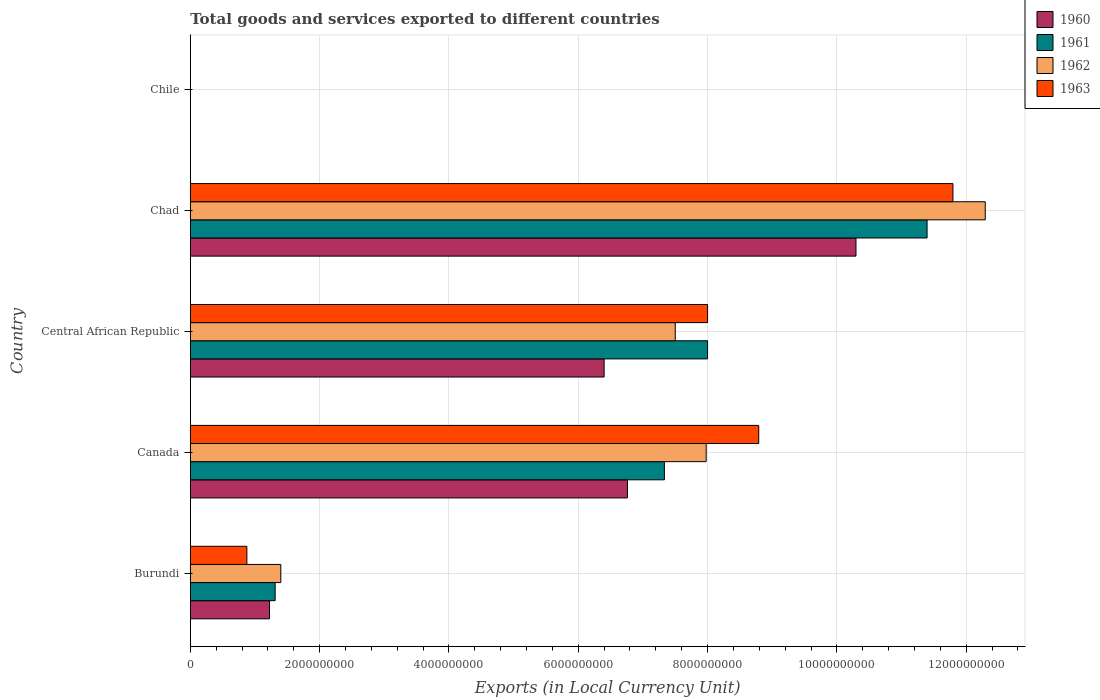How many different coloured bars are there?
Your response must be concise. 4. Are the number of bars per tick equal to the number of legend labels?
Offer a very short reply. Yes. How many bars are there on the 3rd tick from the bottom?
Make the answer very short. 4. What is the label of the 2nd group of bars from the top?
Keep it short and to the point. Chad. In how many cases, is the number of bars for a given country not equal to the number of legend labels?
Your answer should be compact. 0. What is the Amount of goods and services exports in 1962 in Burundi?
Provide a succinct answer. 1.40e+09. Across all countries, what is the maximum Amount of goods and services exports in 1963?
Give a very brief answer. 1.18e+1. Across all countries, what is the minimum Amount of goods and services exports in 1963?
Keep it short and to the point. 1.10e+06. In which country was the Amount of goods and services exports in 1961 maximum?
Offer a very short reply. Chad. What is the total Amount of goods and services exports in 1962 in the graph?
Your answer should be very brief. 2.92e+1. What is the difference between the Amount of goods and services exports in 1963 in Canada and that in Central African Republic?
Your response must be concise. 7.91e+08. What is the difference between the Amount of goods and services exports in 1960 in Chile and the Amount of goods and services exports in 1961 in Canada?
Provide a succinct answer. -7.33e+09. What is the average Amount of goods and services exports in 1962 per country?
Your answer should be very brief. 5.83e+09. What is the difference between the Amount of goods and services exports in 1962 and Amount of goods and services exports in 1963 in Canada?
Offer a very short reply. -8.13e+08. What is the ratio of the Amount of goods and services exports in 1963 in Burundi to that in Chad?
Offer a terse response. 0.07. What is the difference between the highest and the second highest Amount of goods and services exports in 1960?
Provide a succinct answer. 3.53e+09. What is the difference between the highest and the lowest Amount of goods and services exports in 1962?
Make the answer very short. 1.23e+1. Is the sum of the Amount of goods and services exports in 1963 in Burundi and Central African Republic greater than the maximum Amount of goods and services exports in 1962 across all countries?
Offer a terse response. No. What does the 2nd bar from the bottom in Central African Republic represents?
Offer a terse response. 1961. Are all the bars in the graph horizontal?
Provide a short and direct response. Yes. How many countries are there in the graph?
Make the answer very short. 5. Does the graph contain grids?
Your response must be concise. Yes. Where does the legend appear in the graph?
Provide a short and direct response. Top right. How many legend labels are there?
Offer a very short reply. 4. How are the legend labels stacked?
Keep it short and to the point. Vertical. What is the title of the graph?
Keep it short and to the point. Total goods and services exported to different countries. What is the label or title of the X-axis?
Offer a very short reply. Exports (in Local Currency Unit). What is the Exports (in Local Currency Unit) in 1960 in Burundi?
Give a very brief answer. 1.22e+09. What is the Exports (in Local Currency Unit) in 1961 in Burundi?
Keep it short and to the point. 1.31e+09. What is the Exports (in Local Currency Unit) in 1962 in Burundi?
Ensure brevity in your answer.  1.40e+09. What is the Exports (in Local Currency Unit) in 1963 in Burundi?
Keep it short and to the point. 8.75e+08. What is the Exports (in Local Currency Unit) of 1960 in Canada?
Your answer should be compact. 6.76e+09. What is the Exports (in Local Currency Unit) of 1961 in Canada?
Ensure brevity in your answer.  7.33e+09. What is the Exports (in Local Currency Unit) in 1962 in Canada?
Give a very brief answer. 7.98e+09. What is the Exports (in Local Currency Unit) of 1963 in Canada?
Ensure brevity in your answer.  8.79e+09. What is the Exports (in Local Currency Unit) in 1960 in Central African Republic?
Offer a terse response. 6.40e+09. What is the Exports (in Local Currency Unit) in 1961 in Central African Republic?
Your answer should be compact. 8.00e+09. What is the Exports (in Local Currency Unit) in 1962 in Central African Republic?
Your response must be concise. 7.50e+09. What is the Exports (in Local Currency Unit) of 1963 in Central African Republic?
Provide a short and direct response. 8.00e+09. What is the Exports (in Local Currency Unit) in 1960 in Chad?
Your response must be concise. 1.03e+1. What is the Exports (in Local Currency Unit) in 1961 in Chad?
Your response must be concise. 1.14e+1. What is the Exports (in Local Currency Unit) in 1962 in Chad?
Keep it short and to the point. 1.23e+1. What is the Exports (in Local Currency Unit) in 1963 in Chad?
Provide a short and direct response. 1.18e+1. What is the Exports (in Local Currency Unit) of 1960 in Chile?
Make the answer very short. 6.00e+05. What is the Exports (in Local Currency Unit) of 1963 in Chile?
Provide a succinct answer. 1.10e+06. Across all countries, what is the maximum Exports (in Local Currency Unit) of 1960?
Make the answer very short. 1.03e+1. Across all countries, what is the maximum Exports (in Local Currency Unit) in 1961?
Make the answer very short. 1.14e+1. Across all countries, what is the maximum Exports (in Local Currency Unit) of 1962?
Keep it short and to the point. 1.23e+1. Across all countries, what is the maximum Exports (in Local Currency Unit) in 1963?
Your response must be concise. 1.18e+1. Across all countries, what is the minimum Exports (in Local Currency Unit) of 1963?
Offer a terse response. 1.10e+06. What is the total Exports (in Local Currency Unit) of 1960 in the graph?
Make the answer very short. 2.47e+1. What is the total Exports (in Local Currency Unit) of 1961 in the graph?
Provide a short and direct response. 2.80e+1. What is the total Exports (in Local Currency Unit) in 1962 in the graph?
Provide a short and direct response. 2.92e+1. What is the total Exports (in Local Currency Unit) of 1963 in the graph?
Your answer should be very brief. 2.95e+1. What is the difference between the Exports (in Local Currency Unit) of 1960 in Burundi and that in Canada?
Keep it short and to the point. -5.54e+09. What is the difference between the Exports (in Local Currency Unit) of 1961 in Burundi and that in Canada?
Keep it short and to the point. -6.02e+09. What is the difference between the Exports (in Local Currency Unit) in 1962 in Burundi and that in Canada?
Your answer should be compact. -6.58e+09. What is the difference between the Exports (in Local Currency Unit) of 1963 in Burundi and that in Canada?
Ensure brevity in your answer.  -7.92e+09. What is the difference between the Exports (in Local Currency Unit) of 1960 in Burundi and that in Central African Republic?
Make the answer very short. -5.18e+09. What is the difference between the Exports (in Local Currency Unit) in 1961 in Burundi and that in Central African Republic?
Make the answer very short. -6.69e+09. What is the difference between the Exports (in Local Currency Unit) of 1962 in Burundi and that in Central African Republic?
Keep it short and to the point. -6.10e+09. What is the difference between the Exports (in Local Currency Unit) in 1963 in Burundi and that in Central African Republic?
Provide a succinct answer. -7.12e+09. What is the difference between the Exports (in Local Currency Unit) of 1960 in Burundi and that in Chad?
Your answer should be compact. -9.07e+09. What is the difference between the Exports (in Local Currency Unit) in 1961 in Burundi and that in Chad?
Ensure brevity in your answer.  -1.01e+1. What is the difference between the Exports (in Local Currency Unit) of 1962 in Burundi and that in Chad?
Provide a succinct answer. -1.09e+1. What is the difference between the Exports (in Local Currency Unit) in 1963 in Burundi and that in Chad?
Your answer should be compact. -1.09e+1. What is the difference between the Exports (in Local Currency Unit) of 1960 in Burundi and that in Chile?
Your answer should be very brief. 1.22e+09. What is the difference between the Exports (in Local Currency Unit) in 1961 in Burundi and that in Chile?
Provide a succinct answer. 1.31e+09. What is the difference between the Exports (in Local Currency Unit) of 1962 in Burundi and that in Chile?
Your response must be concise. 1.40e+09. What is the difference between the Exports (in Local Currency Unit) in 1963 in Burundi and that in Chile?
Ensure brevity in your answer.  8.74e+08. What is the difference between the Exports (in Local Currency Unit) in 1960 in Canada and that in Central African Republic?
Provide a succinct answer. 3.61e+08. What is the difference between the Exports (in Local Currency Unit) of 1961 in Canada and that in Central African Republic?
Keep it short and to the point. -6.68e+08. What is the difference between the Exports (in Local Currency Unit) of 1962 in Canada and that in Central African Republic?
Ensure brevity in your answer.  4.78e+08. What is the difference between the Exports (in Local Currency Unit) of 1963 in Canada and that in Central African Republic?
Your answer should be very brief. 7.91e+08. What is the difference between the Exports (in Local Currency Unit) in 1960 in Canada and that in Chad?
Ensure brevity in your answer.  -3.53e+09. What is the difference between the Exports (in Local Currency Unit) in 1961 in Canada and that in Chad?
Offer a very short reply. -4.06e+09. What is the difference between the Exports (in Local Currency Unit) of 1962 in Canada and that in Chad?
Keep it short and to the point. -4.32e+09. What is the difference between the Exports (in Local Currency Unit) in 1963 in Canada and that in Chad?
Make the answer very short. -3.00e+09. What is the difference between the Exports (in Local Currency Unit) in 1960 in Canada and that in Chile?
Provide a succinct answer. 6.76e+09. What is the difference between the Exports (in Local Currency Unit) of 1961 in Canada and that in Chile?
Keep it short and to the point. 7.33e+09. What is the difference between the Exports (in Local Currency Unit) of 1962 in Canada and that in Chile?
Your response must be concise. 7.98e+09. What is the difference between the Exports (in Local Currency Unit) in 1963 in Canada and that in Chile?
Give a very brief answer. 8.79e+09. What is the difference between the Exports (in Local Currency Unit) in 1960 in Central African Republic and that in Chad?
Your answer should be compact. -3.90e+09. What is the difference between the Exports (in Local Currency Unit) of 1961 in Central African Republic and that in Chad?
Give a very brief answer. -3.39e+09. What is the difference between the Exports (in Local Currency Unit) in 1962 in Central African Republic and that in Chad?
Your answer should be compact. -4.79e+09. What is the difference between the Exports (in Local Currency Unit) of 1963 in Central African Republic and that in Chad?
Make the answer very short. -3.79e+09. What is the difference between the Exports (in Local Currency Unit) in 1960 in Central African Republic and that in Chile?
Provide a succinct answer. 6.40e+09. What is the difference between the Exports (in Local Currency Unit) of 1961 in Central African Republic and that in Chile?
Your answer should be very brief. 8.00e+09. What is the difference between the Exports (in Local Currency Unit) of 1962 in Central African Republic and that in Chile?
Keep it short and to the point. 7.50e+09. What is the difference between the Exports (in Local Currency Unit) of 1963 in Central African Republic and that in Chile?
Your answer should be compact. 8.00e+09. What is the difference between the Exports (in Local Currency Unit) in 1960 in Chad and that in Chile?
Provide a succinct answer. 1.03e+1. What is the difference between the Exports (in Local Currency Unit) in 1961 in Chad and that in Chile?
Your response must be concise. 1.14e+1. What is the difference between the Exports (in Local Currency Unit) in 1962 in Chad and that in Chile?
Your response must be concise. 1.23e+1. What is the difference between the Exports (in Local Currency Unit) in 1963 in Chad and that in Chile?
Make the answer very short. 1.18e+1. What is the difference between the Exports (in Local Currency Unit) in 1960 in Burundi and the Exports (in Local Currency Unit) in 1961 in Canada?
Ensure brevity in your answer.  -6.11e+09. What is the difference between the Exports (in Local Currency Unit) of 1960 in Burundi and the Exports (in Local Currency Unit) of 1962 in Canada?
Keep it short and to the point. -6.75e+09. What is the difference between the Exports (in Local Currency Unit) of 1960 in Burundi and the Exports (in Local Currency Unit) of 1963 in Canada?
Ensure brevity in your answer.  -7.57e+09. What is the difference between the Exports (in Local Currency Unit) of 1961 in Burundi and the Exports (in Local Currency Unit) of 1962 in Canada?
Provide a short and direct response. -6.67e+09. What is the difference between the Exports (in Local Currency Unit) in 1961 in Burundi and the Exports (in Local Currency Unit) in 1963 in Canada?
Your answer should be very brief. -7.48e+09. What is the difference between the Exports (in Local Currency Unit) of 1962 in Burundi and the Exports (in Local Currency Unit) of 1963 in Canada?
Provide a succinct answer. -7.39e+09. What is the difference between the Exports (in Local Currency Unit) in 1960 in Burundi and the Exports (in Local Currency Unit) in 1961 in Central African Republic?
Your answer should be compact. -6.78e+09. What is the difference between the Exports (in Local Currency Unit) of 1960 in Burundi and the Exports (in Local Currency Unit) of 1962 in Central African Republic?
Make the answer very short. -6.28e+09. What is the difference between the Exports (in Local Currency Unit) of 1960 in Burundi and the Exports (in Local Currency Unit) of 1963 in Central African Republic?
Provide a succinct answer. -6.78e+09. What is the difference between the Exports (in Local Currency Unit) in 1961 in Burundi and the Exports (in Local Currency Unit) in 1962 in Central African Republic?
Keep it short and to the point. -6.19e+09. What is the difference between the Exports (in Local Currency Unit) of 1961 in Burundi and the Exports (in Local Currency Unit) of 1963 in Central African Republic?
Ensure brevity in your answer.  -6.69e+09. What is the difference between the Exports (in Local Currency Unit) in 1962 in Burundi and the Exports (in Local Currency Unit) in 1963 in Central African Republic?
Make the answer very short. -6.60e+09. What is the difference between the Exports (in Local Currency Unit) in 1960 in Burundi and the Exports (in Local Currency Unit) in 1961 in Chad?
Provide a succinct answer. -1.02e+1. What is the difference between the Exports (in Local Currency Unit) of 1960 in Burundi and the Exports (in Local Currency Unit) of 1962 in Chad?
Keep it short and to the point. -1.11e+1. What is the difference between the Exports (in Local Currency Unit) of 1960 in Burundi and the Exports (in Local Currency Unit) of 1963 in Chad?
Offer a very short reply. -1.06e+1. What is the difference between the Exports (in Local Currency Unit) in 1961 in Burundi and the Exports (in Local Currency Unit) in 1962 in Chad?
Give a very brief answer. -1.10e+1. What is the difference between the Exports (in Local Currency Unit) in 1961 in Burundi and the Exports (in Local Currency Unit) in 1963 in Chad?
Your answer should be compact. -1.05e+1. What is the difference between the Exports (in Local Currency Unit) of 1962 in Burundi and the Exports (in Local Currency Unit) of 1963 in Chad?
Give a very brief answer. -1.04e+1. What is the difference between the Exports (in Local Currency Unit) in 1960 in Burundi and the Exports (in Local Currency Unit) in 1961 in Chile?
Your answer should be compact. 1.22e+09. What is the difference between the Exports (in Local Currency Unit) of 1960 in Burundi and the Exports (in Local Currency Unit) of 1962 in Chile?
Provide a succinct answer. 1.22e+09. What is the difference between the Exports (in Local Currency Unit) of 1960 in Burundi and the Exports (in Local Currency Unit) of 1963 in Chile?
Make the answer very short. 1.22e+09. What is the difference between the Exports (in Local Currency Unit) in 1961 in Burundi and the Exports (in Local Currency Unit) in 1962 in Chile?
Provide a short and direct response. 1.31e+09. What is the difference between the Exports (in Local Currency Unit) in 1961 in Burundi and the Exports (in Local Currency Unit) in 1963 in Chile?
Offer a very short reply. 1.31e+09. What is the difference between the Exports (in Local Currency Unit) of 1962 in Burundi and the Exports (in Local Currency Unit) of 1963 in Chile?
Make the answer very short. 1.40e+09. What is the difference between the Exports (in Local Currency Unit) of 1960 in Canada and the Exports (in Local Currency Unit) of 1961 in Central African Republic?
Offer a terse response. -1.24e+09. What is the difference between the Exports (in Local Currency Unit) in 1960 in Canada and the Exports (in Local Currency Unit) in 1962 in Central African Republic?
Your answer should be compact. -7.39e+08. What is the difference between the Exports (in Local Currency Unit) in 1960 in Canada and the Exports (in Local Currency Unit) in 1963 in Central African Republic?
Offer a terse response. -1.24e+09. What is the difference between the Exports (in Local Currency Unit) in 1961 in Canada and the Exports (in Local Currency Unit) in 1962 in Central African Republic?
Offer a terse response. -1.68e+08. What is the difference between the Exports (in Local Currency Unit) in 1961 in Canada and the Exports (in Local Currency Unit) in 1963 in Central African Republic?
Your answer should be compact. -6.68e+08. What is the difference between the Exports (in Local Currency Unit) of 1962 in Canada and the Exports (in Local Currency Unit) of 1963 in Central African Republic?
Ensure brevity in your answer.  -2.17e+07. What is the difference between the Exports (in Local Currency Unit) in 1960 in Canada and the Exports (in Local Currency Unit) in 1961 in Chad?
Your response must be concise. -4.63e+09. What is the difference between the Exports (in Local Currency Unit) in 1960 in Canada and the Exports (in Local Currency Unit) in 1962 in Chad?
Offer a terse response. -5.53e+09. What is the difference between the Exports (in Local Currency Unit) of 1960 in Canada and the Exports (in Local Currency Unit) of 1963 in Chad?
Provide a succinct answer. -5.03e+09. What is the difference between the Exports (in Local Currency Unit) in 1961 in Canada and the Exports (in Local Currency Unit) in 1962 in Chad?
Keep it short and to the point. -4.96e+09. What is the difference between the Exports (in Local Currency Unit) in 1961 in Canada and the Exports (in Local Currency Unit) in 1963 in Chad?
Offer a terse response. -4.46e+09. What is the difference between the Exports (in Local Currency Unit) in 1962 in Canada and the Exports (in Local Currency Unit) in 1963 in Chad?
Your answer should be compact. -3.82e+09. What is the difference between the Exports (in Local Currency Unit) in 1960 in Canada and the Exports (in Local Currency Unit) in 1961 in Chile?
Make the answer very short. 6.76e+09. What is the difference between the Exports (in Local Currency Unit) in 1960 in Canada and the Exports (in Local Currency Unit) in 1962 in Chile?
Offer a very short reply. 6.76e+09. What is the difference between the Exports (in Local Currency Unit) of 1960 in Canada and the Exports (in Local Currency Unit) of 1963 in Chile?
Your answer should be compact. 6.76e+09. What is the difference between the Exports (in Local Currency Unit) of 1961 in Canada and the Exports (in Local Currency Unit) of 1962 in Chile?
Provide a short and direct response. 7.33e+09. What is the difference between the Exports (in Local Currency Unit) of 1961 in Canada and the Exports (in Local Currency Unit) of 1963 in Chile?
Give a very brief answer. 7.33e+09. What is the difference between the Exports (in Local Currency Unit) of 1962 in Canada and the Exports (in Local Currency Unit) of 1963 in Chile?
Your response must be concise. 7.98e+09. What is the difference between the Exports (in Local Currency Unit) of 1960 in Central African Republic and the Exports (in Local Currency Unit) of 1961 in Chad?
Keep it short and to the point. -4.99e+09. What is the difference between the Exports (in Local Currency Unit) of 1960 in Central African Republic and the Exports (in Local Currency Unit) of 1962 in Chad?
Your response must be concise. -5.89e+09. What is the difference between the Exports (in Local Currency Unit) in 1960 in Central African Republic and the Exports (in Local Currency Unit) in 1963 in Chad?
Your answer should be compact. -5.39e+09. What is the difference between the Exports (in Local Currency Unit) of 1961 in Central African Republic and the Exports (in Local Currency Unit) of 1962 in Chad?
Give a very brief answer. -4.29e+09. What is the difference between the Exports (in Local Currency Unit) in 1961 in Central African Republic and the Exports (in Local Currency Unit) in 1963 in Chad?
Provide a succinct answer. -3.79e+09. What is the difference between the Exports (in Local Currency Unit) in 1962 in Central African Republic and the Exports (in Local Currency Unit) in 1963 in Chad?
Provide a succinct answer. -4.29e+09. What is the difference between the Exports (in Local Currency Unit) in 1960 in Central African Republic and the Exports (in Local Currency Unit) in 1961 in Chile?
Ensure brevity in your answer.  6.40e+09. What is the difference between the Exports (in Local Currency Unit) in 1960 in Central African Republic and the Exports (in Local Currency Unit) in 1962 in Chile?
Offer a terse response. 6.40e+09. What is the difference between the Exports (in Local Currency Unit) of 1960 in Central African Republic and the Exports (in Local Currency Unit) of 1963 in Chile?
Ensure brevity in your answer.  6.40e+09. What is the difference between the Exports (in Local Currency Unit) of 1961 in Central African Republic and the Exports (in Local Currency Unit) of 1962 in Chile?
Provide a short and direct response. 8.00e+09. What is the difference between the Exports (in Local Currency Unit) in 1961 in Central African Republic and the Exports (in Local Currency Unit) in 1963 in Chile?
Provide a succinct answer. 8.00e+09. What is the difference between the Exports (in Local Currency Unit) in 1962 in Central African Republic and the Exports (in Local Currency Unit) in 1963 in Chile?
Offer a terse response. 7.50e+09. What is the difference between the Exports (in Local Currency Unit) of 1960 in Chad and the Exports (in Local Currency Unit) of 1961 in Chile?
Provide a short and direct response. 1.03e+1. What is the difference between the Exports (in Local Currency Unit) of 1960 in Chad and the Exports (in Local Currency Unit) of 1962 in Chile?
Make the answer very short. 1.03e+1. What is the difference between the Exports (in Local Currency Unit) of 1960 in Chad and the Exports (in Local Currency Unit) of 1963 in Chile?
Your response must be concise. 1.03e+1. What is the difference between the Exports (in Local Currency Unit) in 1961 in Chad and the Exports (in Local Currency Unit) in 1962 in Chile?
Provide a succinct answer. 1.14e+1. What is the difference between the Exports (in Local Currency Unit) in 1961 in Chad and the Exports (in Local Currency Unit) in 1963 in Chile?
Ensure brevity in your answer.  1.14e+1. What is the difference between the Exports (in Local Currency Unit) in 1962 in Chad and the Exports (in Local Currency Unit) in 1963 in Chile?
Provide a succinct answer. 1.23e+1. What is the average Exports (in Local Currency Unit) in 1960 per country?
Your answer should be compact. 4.94e+09. What is the average Exports (in Local Currency Unit) of 1961 per country?
Provide a succinct answer. 5.61e+09. What is the average Exports (in Local Currency Unit) of 1962 per country?
Your answer should be very brief. 5.83e+09. What is the average Exports (in Local Currency Unit) of 1963 per country?
Provide a succinct answer. 5.89e+09. What is the difference between the Exports (in Local Currency Unit) in 1960 and Exports (in Local Currency Unit) in 1961 in Burundi?
Your answer should be very brief. -8.75e+07. What is the difference between the Exports (in Local Currency Unit) of 1960 and Exports (in Local Currency Unit) of 1962 in Burundi?
Make the answer very short. -1.75e+08. What is the difference between the Exports (in Local Currency Unit) in 1960 and Exports (in Local Currency Unit) in 1963 in Burundi?
Keep it short and to the point. 3.50e+08. What is the difference between the Exports (in Local Currency Unit) in 1961 and Exports (in Local Currency Unit) in 1962 in Burundi?
Your response must be concise. -8.75e+07. What is the difference between the Exports (in Local Currency Unit) of 1961 and Exports (in Local Currency Unit) of 1963 in Burundi?
Offer a terse response. 4.38e+08. What is the difference between the Exports (in Local Currency Unit) of 1962 and Exports (in Local Currency Unit) of 1963 in Burundi?
Offer a terse response. 5.25e+08. What is the difference between the Exports (in Local Currency Unit) in 1960 and Exports (in Local Currency Unit) in 1961 in Canada?
Offer a very short reply. -5.71e+08. What is the difference between the Exports (in Local Currency Unit) of 1960 and Exports (in Local Currency Unit) of 1962 in Canada?
Make the answer very short. -1.22e+09. What is the difference between the Exports (in Local Currency Unit) in 1960 and Exports (in Local Currency Unit) in 1963 in Canada?
Make the answer very short. -2.03e+09. What is the difference between the Exports (in Local Currency Unit) of 1961 and Exports (in Local Currency Unit) of 1962 in Canada?
Give a very brief answer. -6.46e+08. What is the difference between the Exports (in Local Currency Unit) of 1961 and Exports (in Local Currency Unit) of 1963 in Canada?
Your answer should be very brief. -1.46e+09. What is the difference between the Exports (in Local Currency Unit) of 1962 and Exports (in Local Currency Unit) of 1963 in Canada?
Your answer should be compact. -8.13e+08. What is the difference between the Exports (in Local Currency Unit) in 1960 and Exports (in Local Currency Unit) in 1961 in Central African Republic?
Ensure brevity in your answer.  -1.60e+09. What is the difference between the Exports (in Local Currency Unit) in 1960 and Exports (in Local Currency Unit) in 1962 in Central African Republic?
Offer a very short reply. -1.10e+09. What is the difference between the Exports (in Local Currency Unit) in 1960 and Exports (in Local Currency Unit) in 1963 in Central African Republic?
Provide a succinct answer. -1.60e+09. What is the difference between the Exports (in Local Currency Unit) of 1961 and Exports (in Local Currency Unit) of 1962 in Central African Republic?
Make the answer very short. 5.00e+08. What is the difference between the Exports (in Local Currency Unit) of 1961 and Exports (in Local Currency Unit) of 1963 in Central African Republic?
Offer a very short reply. 0. What is the difference between the Exports (in Local Currency Unit) in 1962 and Exports (in Local Currency Unit) in 1963 in Central African Republic?
Ensure brevity in your answer.  -5.00e+08. What is the difference between the Exports (in Local Currency Unit) in 1960 and Exports (in Local Currency Unit) in 1961 in Chad?
Make the answer very short. -1.10e+09. What is the difference between the Exports (in Local Currency Unit) in 1960 and Exports (in Local Currency Unit) in 1962 in Chad?
Offer a terse response. -2.00e+09. What is the difference between the Exports (in Local Currency Unit) of 1960 and Exports (in Local Currency Unit) of 1963 in Chad?
Make the answer very short. -1.50e+09. What is the difference between the Exports (in Local Currency Unit) of 1961 and Exports (in Local Currency Unit) of 1962 in Chad?
Your answer should be compact. -9.00e+08. What is the difference between the Exports (in Local Currency Unit) of 1961 and Exports (in Local Currency Unit) of 1963 in Chad?
Make the answer very short. -4.00e+08. What is the difference between the Exports (in Local Currency Unit) of 1962 and Exports (in Local Currency Unit) of 1963 in Chad?
Your answer should be compact. 5.00e+08. What is the difference between the Exports (in Local Currency Unit) of 1960 and Exports (in Local Currency Unit) of 1961 in Chile?
Provide a short and direct response. 0. What is the difference between the Exports (in Local Currency Unit) in 1960 and Exports (in Local Currency Unit) in 1962 in Chile?
Offer a terse response. -1.00e+05. What is the difference between the Exports (in Local Currency Unit) in 1960 and Exports (in Local Currency Unit) in 1963 in Chile?
Your response must be concise. -5.00e+05. What is the difference between the Exports (in Local Currency Unit) in 1961 and Exports (in Local Currency Unit) in 1963 in Chile?
Make the answer very short. -5.00e+05. What is the difference between the Exports (in Local Currency Unit) of 1962 and Exports (in Local Currency Unit) of 1963 in Chile?
Your response must be concise. -4.00e+05. What is the ratio of the Exports (in Local Currency Unit) in 1960 in Burundi to that in Canada?
Ensure brevity in your answer.  0.18. What is the ratio of the Exports (in Local Currency Unit) of 1961 in Burundi to that in Canada?
Your answer should be compact. 0.18. What is the ratio of the Exports (in Local Currency Unit) in 1962 in Burundi to that in Canada?
Offer a very short reply. 0.18. What is the ratio of the Exports (in Local Currency Unit) in 1963 in Burundi to that in Canada?
Offer a terse response. 0.1. What is the ratio of the Exports (in Local Currency Unit) in 1960 in Burundi to that in Central African Republic?
Ensure brevity in your answer.  0.19. What is the ratio of the Exports (in Local Currency Unit) of 1961 in Burundi to that in Central African Republic?
Ensure brevity in your answer.  0.16. What is the ratio of the Exports (in Local Currency Unit) of 1962 in Burundi to that in Central African Republic?
Offer a terse response. 0.19. What is the ratio of the Exports (in Local Currency Unit) of 1963 in Burundi to that in Central African Republic?
Your answer should be compact. 0.11. What is the ratio of the Exports (in Local Currency Unit) in 1960 in Burundi to that in Chad?
Keep it short and to the point. 0.12. What is the ratio of the Exports (in Local Currency Unit) of 1961 in Burundi to that in Chad?
Your response must be concise. 0.12. What is the ratio of the Exports (in Local Currency Unit) of 1962 in Burundi to that in Chad?
Make the answer very short. 0.11. What is the ratio of the Exports (in Local Currency Unit) in 1963 in Burundi to that in Chad?
Keep it short and to the point. 0.07. What is the ratio of the Exports (in Local Currency Unit) in 1960 in Burundi to that in Chile?
Your response must be concise. 2041.67. What is the ratio of the Exports (in Local Currency Unit) of 1961 in Burundi to that in Chile?
Keep it short and to the point. 2187.5. What is the ratio of the Exports (in Local Currency Unit) of 1962 in Burundi to that in Chile?
Keep it short and to the point. 2000. What is the ratio of the Exports (in Local Currency Unit) of 1963 in Burundi to that in Chile?
Ensure brevity in your answer.  795.45. What is the ratio of the Exports (in Local Currency Unit) of 1960 in Canada to that in Central African Republic?
Ensure brevity in your answer.  1.06. What is the ratio of the Exports (in Local Currency Unit) in 1961 in Canada to that in Central African Republic?
Give a very brief answer. 0.92. What is the ratio of the Exports (in Local Currency Unit) in 1962 in Canada to that in Central African Republic?
Offer a very short reply. 1.06. What is the ratio of the Exports (in Local Currency Unit) of 1963 in Canada to that in Central African Republic?
Offer a terse response. 1.1. What is the ratio of the Exports (in Local Currency Unit) of 1960 in Canada to that in Chad?
Offer a very short reply. 0.66. What is the ratio of the Exports (in Local Currency Unit) in 1961 in Canada to that in Chad?
Give a very brief answer. 0.64. What is the ratio of the Exports (in Local Currency Unit) of 1962 in Canada to that in Chad?
Offer a terse response. 0.65. What is the ratio of the Exports (in Local Currency Unit) of 1963 in Canada to that in Chad?
Provide a short and direct response. 0.75. What is the ratio of the Exports (in Local Currency Unit) of 1960 in Canada to that in Chile?
Ensure brevity in your answer.  1.13e+04. What is the ratio of the Exports (in Local Currency Unit) in 1961 in Canada to that in Chile?
Your answer should be compact. 1.22e+04. What is the ratio of the Exports (in Local Currency Unit) of 1962 in Canada to that in Chile?
Give a very brief answer. 1.14e+04. What is the ratio of the Exports (in Local Currency Unit) in 1963 in Canada to that in Chile?
Provide a short and direct response. 7992.05. What is the ratio of the Exports (in Local Currency Unit) of 1960 in Central African Republic to that in Chad?
Your answer should be compact. 0.62. What is the ratio of the Exports (in Local Currency Unit) of 1961 in Central African Republic to that in Chad?
Your answer should be very brief. 0.7. What is the ratio of the Exports (in Local Currency Unit) of 1962 in Central African Republic to that in Chad?
Provide a succinct answer. 0.61. What is the ratio of the Exports (in Local Currency Unit) in 1963 in Central African Republic to that in Chad?
Your response must be concise. 0.68. What is the ratio of the Exports (in Local Currency Unit) in 1960 in Central African Republic to that in Chile?
Give a very brief answer. 1.07e+04. What is the ratio of the Exports (in Local Currency Unit) in 1961 in Central African Republic to that in Chile?
Your answer should be very brief. 1.33e+04. What is the ratio of the Exports (in Local Currency Unit) in 1962 in Central African Republic to that in Chile?
Provide a succinct answer. 1.07e+04. What is the ratio of the Exports (in Local Currency Unit) of 1963 in Central African Republic to that in Chile?
Offer a terse response. 7272.73. What is the ratio of the Exports (in Local Currency Unit) in 1960 in Chad to that in Chile?
Your answer should be compact. 1.72e+04. What is the ratio of the Exports (in Local Currency Unit) of 1961 in Chad to that in Chile?
Offer a terse response. 1.90e+04. What is the ratio of the Exports (in Local Currency Unit) in 1962 in Chad to that in Chile?
Offer a very short reply. 1.76e+04. What is the ratio of the Exports (in Local Currency Unit) of 1963 in Chad to that in Chile?
Give a very brief answer. 1.07e+04. What is the difference between the highest and the second highest Exports (in Local Currency Unit) in 1960?
Provide a succinct answer. 3.53e+09. What is the difference between the highest and the second highest Exports (in Local Currency Unit) of 1961?
Offer a very short reply. 3.39e+09. What is the difference between the highest and the second highest Exports (in Local Currency Unit) of 1962?
Your response must be concise. 4.32e+09. What is the difference between the highest and the second highest Exports (in Local Currency Unit) in 1963?
Your response must be concise. 3.00e+09. What is the difference between the highest and the lowest Exports (in Local Currency Unit) in 1960?
Your answer should be very brief. 1.03e+1. What is the difference between the highest and the lowest Exports (in Local Currency Unit) in 1961?
Your answer should be very brief. 1.14e+1. What is the difference between the highest and the lowest Exports (in Local Currency Unit) in 1962?
Offer a very short reply. 1.23e+1. What is the difference between the highest and the lowest Exports (in Local Currency Unit) in 1963?
Offer a terse response. 1.18e+1. 